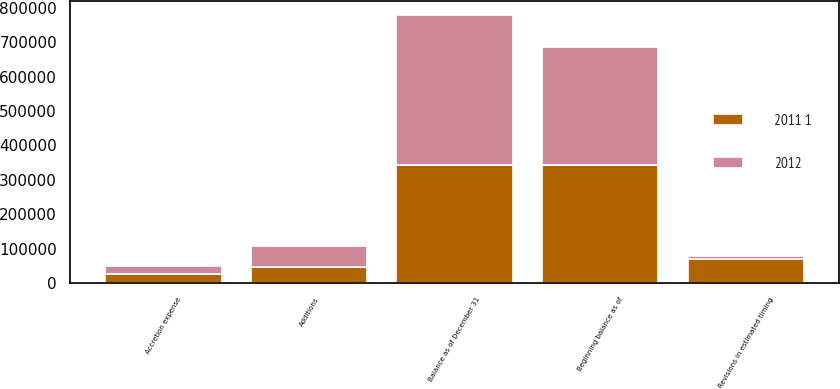Convert chart to OTSL. <chart><loc_0><loc_0><loc_500><loc_500><stacked_bar_chart><ecel><fcel>Beginning balance as of<fcel>Additions<fcel>Revisions in estimated timing<fcel>Accretion expense<fcel>Balance as of December 31<nl><fcel>2012<fcel>344180<fcel>59847<fcel>6641<fcel>25056<fcel>435724<nl><fcel>2011 1<fcel>341838<fcel>47426<fcel>70755<fcel>25671<fcel>344180<nl></chart> 